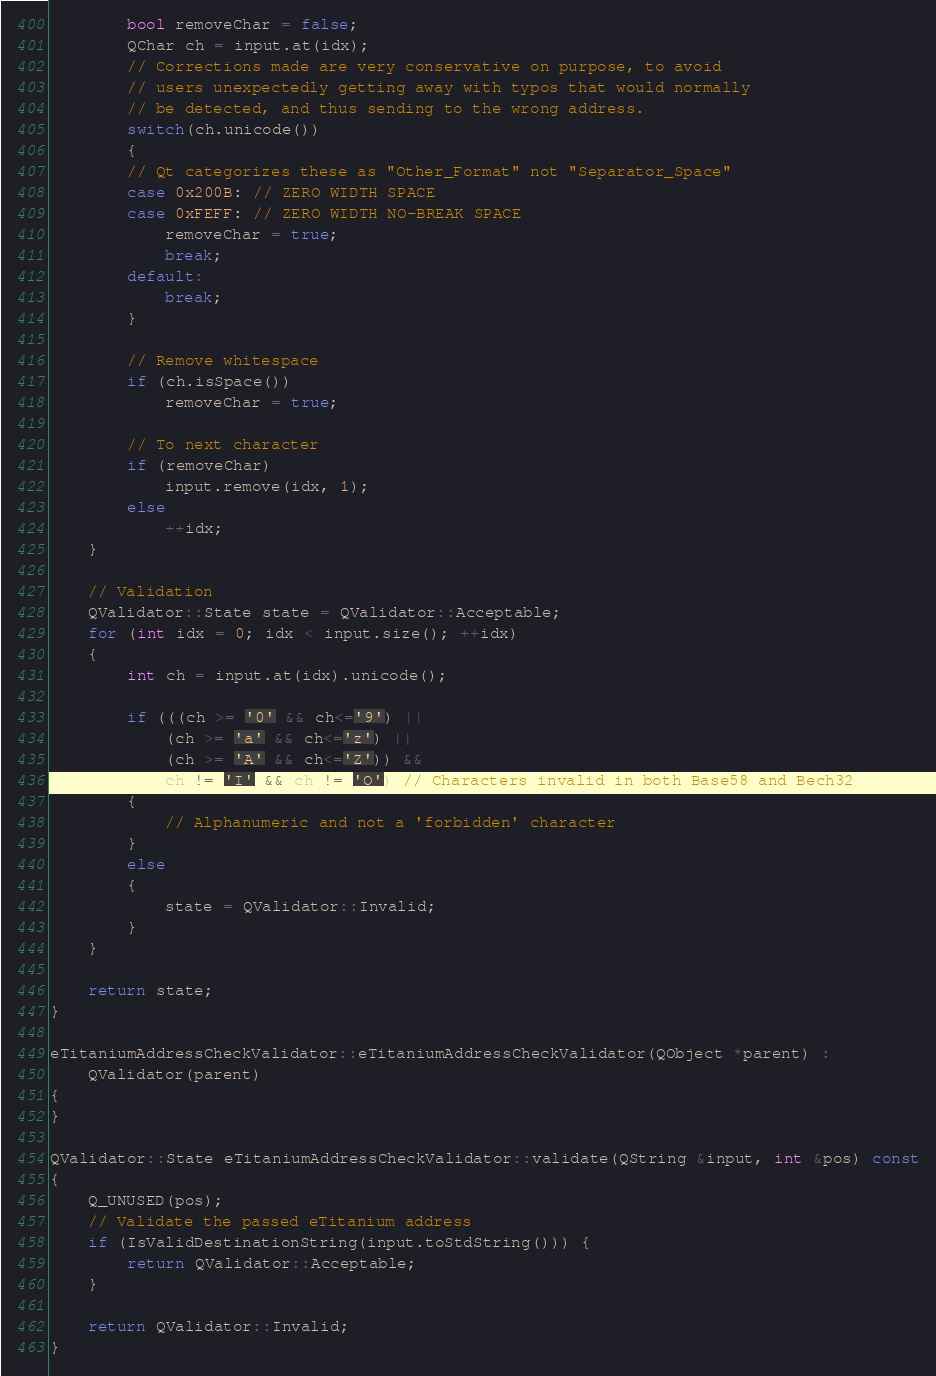Convert code to text. <code><loc_0><loc_0><loc_500><loc_500><_C++_>        bool removeChar = false;
        QChar ch = input.at(idx);
        // Corrections made are very conservative on purpose, to avoid
        // users unexpectedly getting away with typos that would normally
        // be detected, and thus sending to the wrong address.
        switch(ch.unicode())
        {
        // Qt categorizes these as "Other_Format" not "Separator_Space"
        case 0x200B: // ZERO WIDTH SPACE
        case 0xFEFF: // ZERO WIDTH NO-BREAK SPACE
            removeChar = true;
            break;
        default:
            break;
        }

        // Remove whitespace
        if (ch.isSpace())
            removeChar = true;

        // To next character
        if (removeChar)
            input.remove(idx, 1);
        else
            ++idx;
    }

    // Validation
    QValidator::State state = QValidator::Acceptable;
    for (int idx = 0; idx < input.size(); ++idx)
    {
        int ch = input.at(idx).unicode();

        if (((ch >= '0' && ch<='9') ||
            (ch >= 'a' && ch<='z') ||
            (ch >= 'A' && ch<='Z')) &&
            ch != 'I' && ch != 'O') // Characters invalid in both Base58 and Bech32
        {
            // Alphanumeric and not a 'forbidden' character
        }
        else
        {
            state = QValidator::Invalid;
        }
    }

    return state;
}

eTitaniumAddressCheckValidator::eTitaniumAddressCheckValidator(QObject *parent) :
    QValidator(parent)
{
}

QValidator::State eTitaniumAddressCheckValidator::validate(QString &input, int &pos) const
{
    Q_UNUSED(pos);
    // Validate the passed eTitanium address
    if (IsValidDestinationString(input.toStdString())) {
        return QValidator::Acceptable;
    }

    return QValidator::Invalid;
}
</code> 